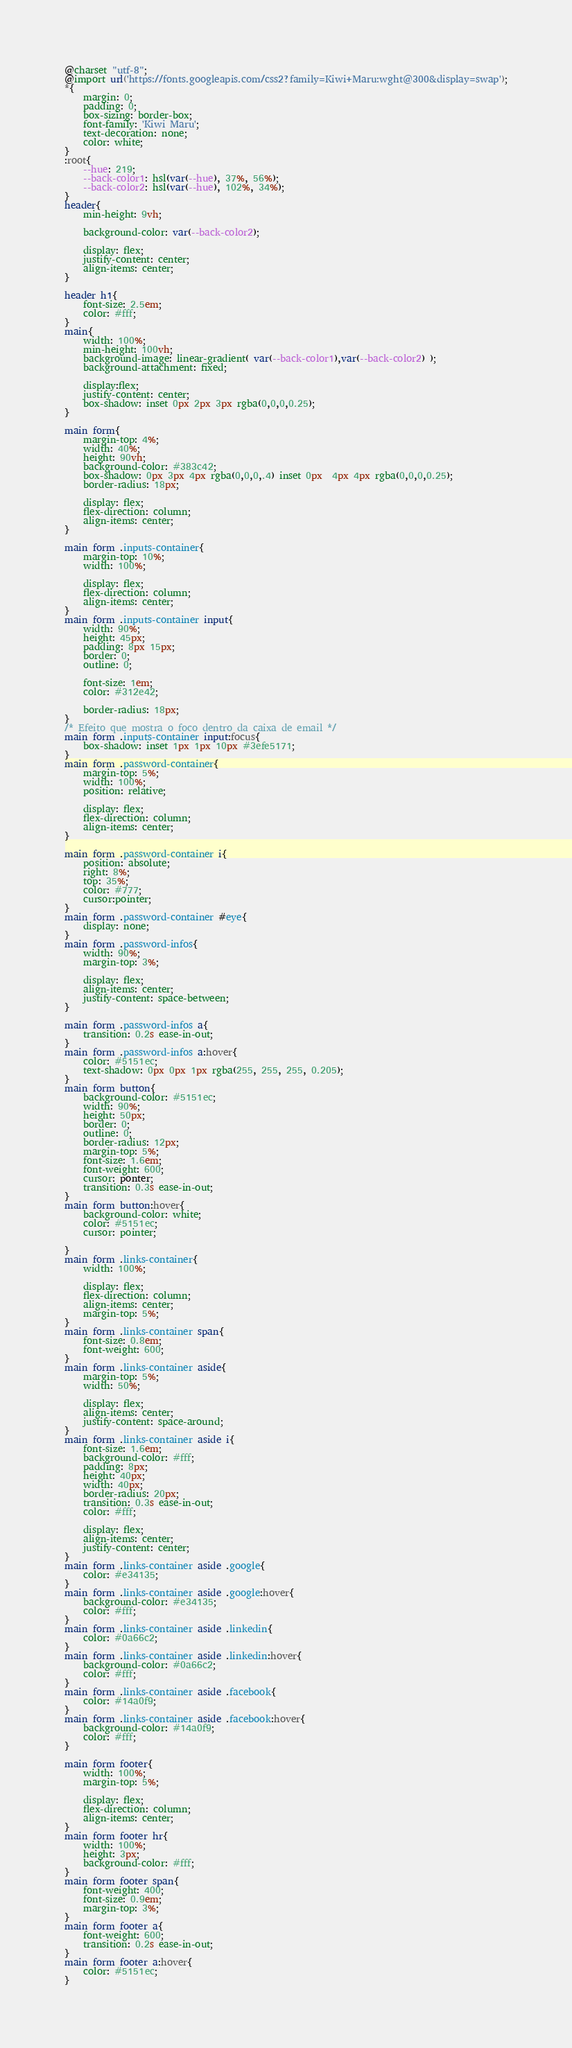Convert code to text. <code><loc_0><loc_0><loc_500><loc_500><_CSS_>@charset "utf-8";
@import url('https://fonts.googleapis.com/css2?family=Kiwi+Maru:wght@300&display=swap');
*{
    margin: 0;
    padding: 0;
    box-sizing: border-box;
    font-family: 'Kiwi Maru';
    text-decoration: none;
    color: white;
}
:root{
    --hue: 219;
    --back-color1: hsl(var(--hue), 37%, 56%);
    --back-color2: hsl(var(--hue), 102%, 34%);
}
header{
    min-height: 9vh;
    
    background-color: var(--back-color2);
    
    display: flex;
    justify-content: center;
    align-items: center;
}

header h1{
    font-size: 2.5em;
    color: #fff;
}
main{
    width: 100%;
    min-height: 100vh;
    background-image: linear-gradient( var(--back-color1),var(--back-color2) );
    background-attachment: fixed;
    
    display:flex;
    justify-content: center;
    box-shadow: inset 0px 2px 3px rgba(0,0,0,0.25);
}

main form{
    margin-top: 4%;
    width: 40%;
    height: 90vh;
    background-color: #383c42;
    box-shadow: 0px 3px 4px rgba(0,0,0,.4) inset 0px  4px 4px rgba(0,0,0,0.25);   
    border-radius: 18px;

    display: flex;
    flex-direction: column;
    align-items: center;
}

main form .inputs-container{
    margin-top: 10%;
    width: 100%;

    display: flex;
    flex-direction: column;
    align-items: center;
}
main form .inputs-container input{
    width: 90%;
    height: 45px;
    padding: 8px 15px;
    border: 0;
    outline: 0;

    font-size: 1em;
    color: #312e42;

    border-radius: 18px;
}
/* Efeito que mostra o foco dentro da caixa de email */
main form .inputs-container input:focus{
    box-shadow: inset 1px 1px 10px #3efe5171;
}
main form .password-container{
    margin-top: 5%;
    width: 100%;
    position: relative;

    display: flex;
    flex-direction: column;
    align-items: center;
}

main form .password-container i{
    position: absolute;
    right: 8%;
    top: 35%;
    color: #777;
    cursor:pointer;
}
main form .password-container #eye{
    display: none;
}
main form .password-infos{
    width: 90%;
    margin-top: 3%;

    display: flex;
    align-items: center;
    justify-content: space-between;
}

main form .password-infos a{
    transition: 0.2s ease-in-out;
}
main form .password-infos a:hover{
    color: #5151ec;
    text-shadow: 0px 0px 1px rgba(255, 255, 255, 0.205);
}
main form button{
    background-color: #5151ec;
    width: 90%;
    height: 50px;
    border: 0;
    outline: 0;
    border-radius: 12px;
    margin-top: 5%;
    font-size: 1.6em;
    font-weight: 600;
    cursor: ponter;
    transition: 0.3s ease-in-out;
}
main form button:hover{
    background-color: white;
    color: #5151ec;
    cursor: pointer;
    
}
main form .links-container{
    width: 100%;

    display: flex;
    flex-direction: column;
    align-items: center;
    margin-top: 5%;
}
main form .links-container span{
    font-size: 0.8em;
    font-weight: 600;
}
main form .links-container aside{
    margin-top: 5%;
    width: 50%;

    display: flex;
    align-items: center;
    justify-content: space-around;
}
main form .links-container aside i{
    font-size: 1.6em;
    background-color: #fff;
    padding: 8px;
    height: 40px;
    width: 40px;
    border-radius: 20px;
    transition: 0.3s ease-in-out;
    color: #fff;

    display: flex;
    align-items: center;
    justify-content: center;
}
main form .links-container aside .google{
    color: #e34135;
}
main form .links-container aside .google:hover{
    background-color: #e34135;
    color: #fff;
}
main form .links-container aside .linkedin{
    color: #0a66c2;
}
main form .links-container aside .linkedin:hover{
    background-color: #0a66c2;
    color: #fff;
}
main form .links-container aside .facebook{
    color: #14a0f9;
}
main form .links-container aside .facebook:hover{
    background-color: #14a0f9;
    color: #fff;
}

main form footer{
    width: 100%;
    margin-top: 5%;

    display: flex;
    flex-direction: column;
    align-items: center;
}
main form footer hr{
    width: 100%;
    height: 3px;
    background-color: #fff;
}
main form footer span{
    font-weight: 400;
    font-size: 0.9em;
    margin-top: 3%;
}
main form footer a{
    font-weight: 600;
    transition: 0.2s ease-in-out;
}
main form footer a:hover{
    color: #5151ec;
}</code> 